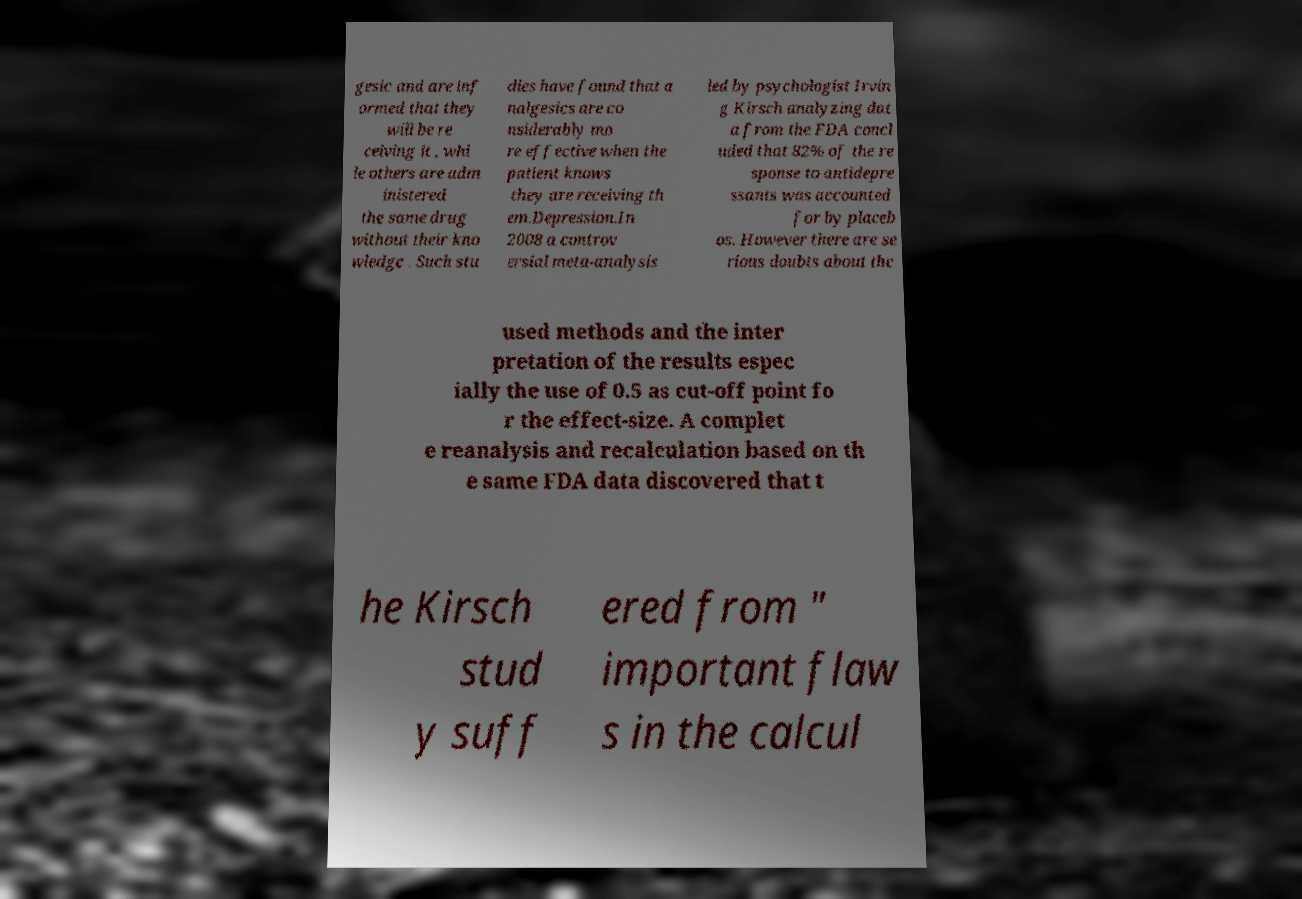Could you assist in decoding the text presented in this image and type it out clearly? gesic and are inf ormed that they will be re ceiving it , whi le others are adm inistered the same drug without their kno wledge . Such stu dies have found that a nalgesics are co nsiderably mo re effective when the patient knows they are receiving th em.Depression.In 2008 a controv ersial meta-analysis led by psychologist Irvin g Kirsch analyzing dat a from the FDA concl uded that 82% of the re sponse to antidepre ssants was accounted for by placeb os. However there are se rious doubts about the used methods and the inter pretation of the results espec ially the use of 0.5 as cut-off point fo r the effect-size. A complet e reanalysis and recalculation based on th e same FDA data discovered that t he Kirsch stud y suff ered from " important flaw s in the calcul 